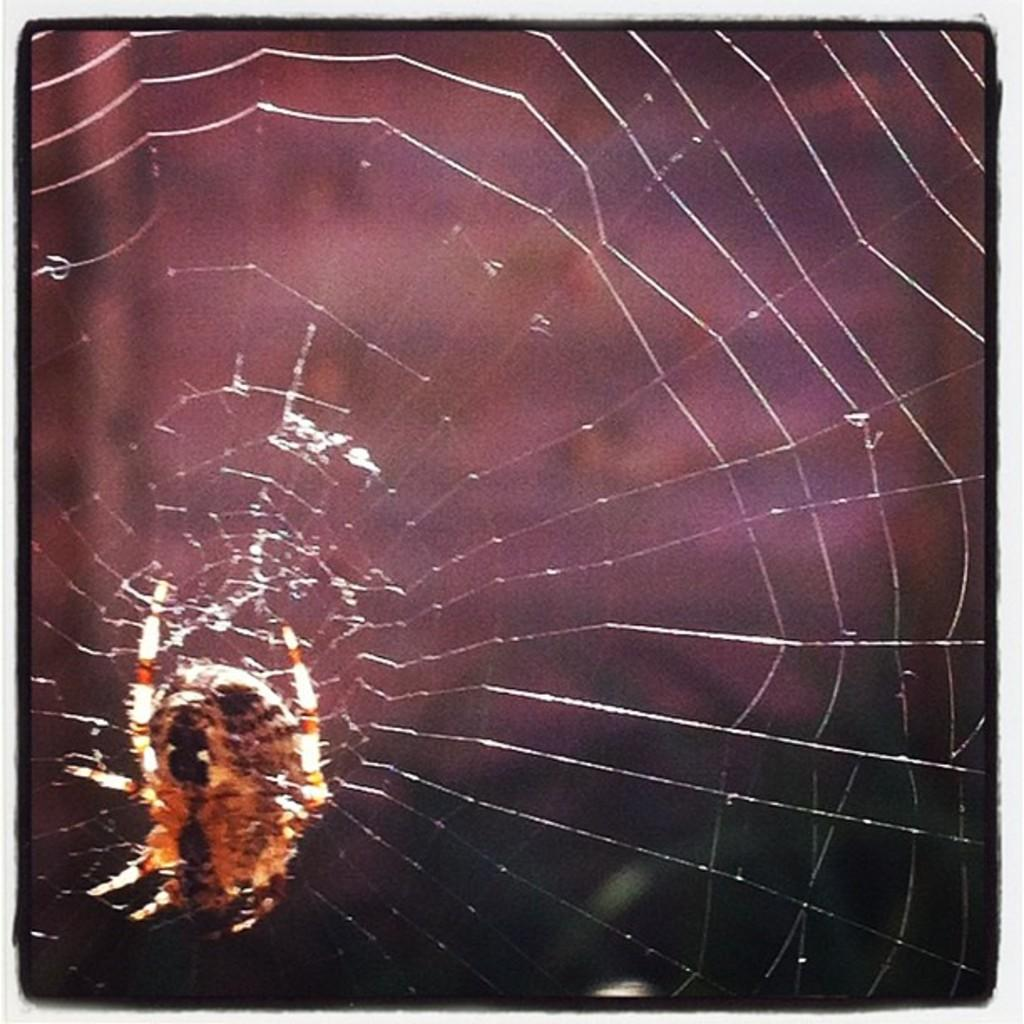What is the main subject of the image? The main subject of the image is a spider. Where is the spider located in the image? The spider is on a spider web. Can you describe the background of the image? The background of the image is blurred. What type of acoustics can be heard from the spider in the image? There is no sound or acoustics associated with the spider in the image, as it is a still photograph. 